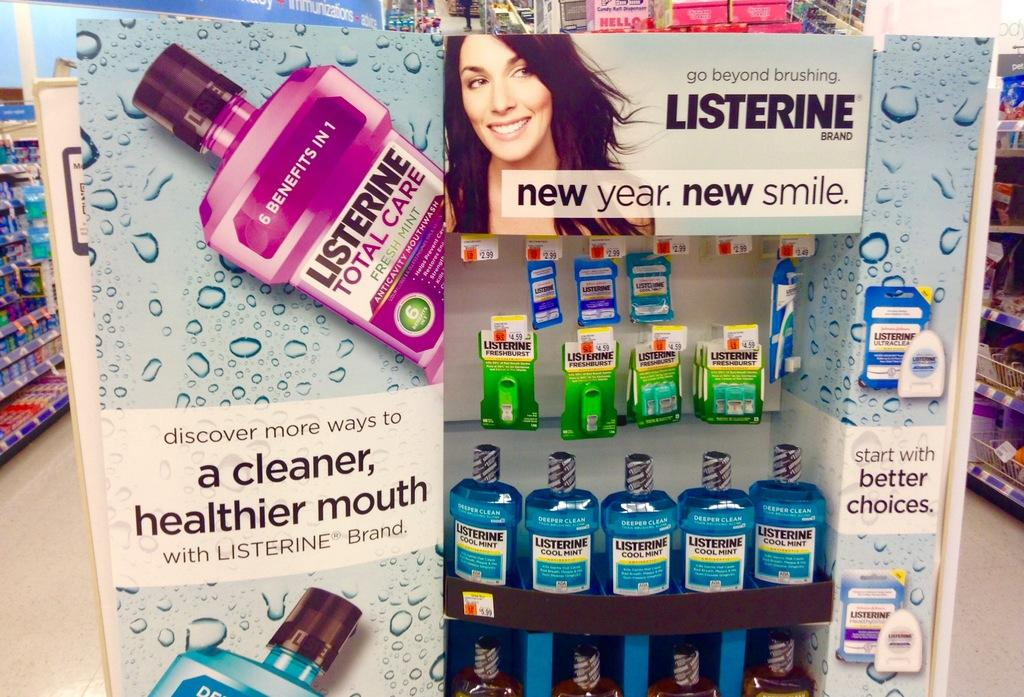Provide a one-sentence caption for the provided image. A Listerine display at the end of an aisle in a store. 